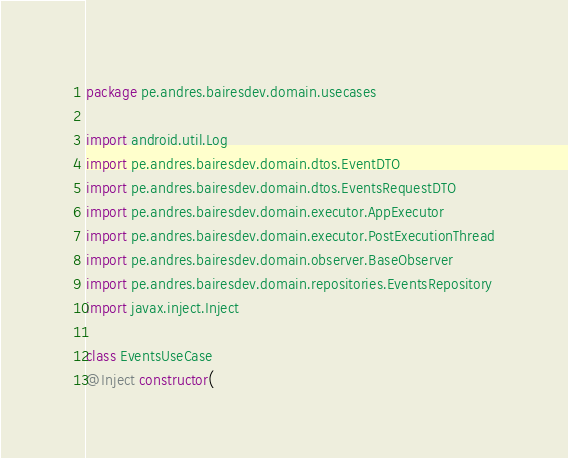<code> <loc_0><loc_0><loc_500><loc_500><_Kotlin_>package pe.andres.bairesdev.domain.usecases

import android.util.Log
import pe.andres.bairesdev.domain.dtos.EventDTO
import pe.andres.bairesdev.domain.dtos.EventsRequestDTO
import pe.andres.bairesdev.domain.executor.AppExecutor
import pe.andres.bairesdev.domain.executor.PostExecutionThread
import pe.andres.bairesdev.domain.observer.BaseObserver
import pe.andres.bairesdev.domain.repositories.EventsRepository
import javax.inject.Inject

class EventsUseCase
@Inject constructor(</code> 